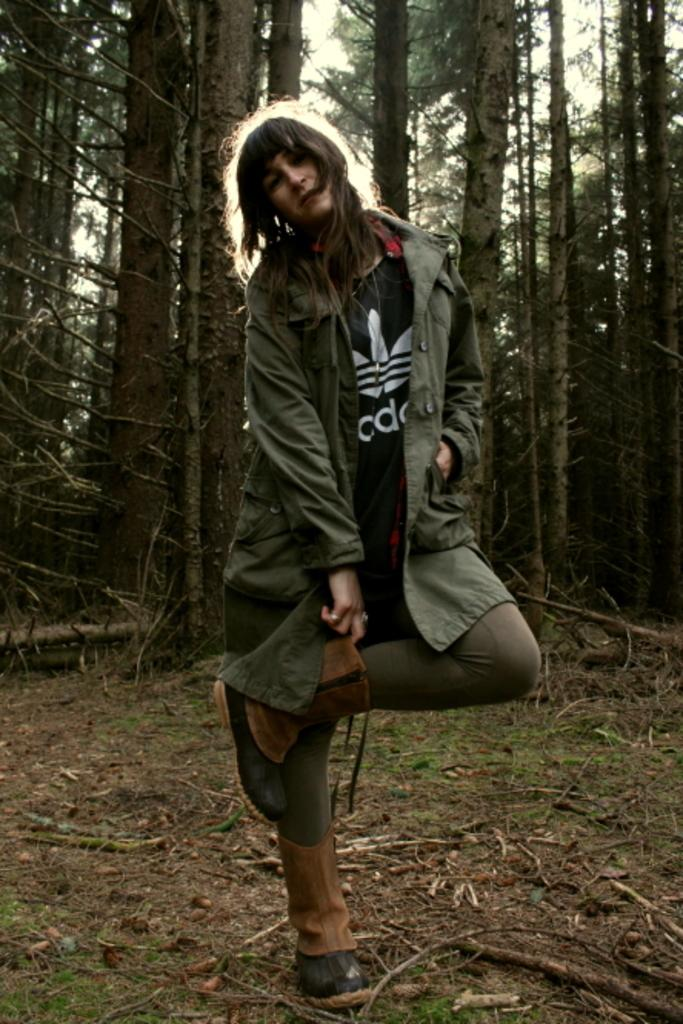Where was the picture taken? The picture was taken outside. What is the main subject in the center of the image? There is a person in the center of the image. What is the person wearing? The person is wearing a jacket. What surface is the person standing on? The person is standing on the ground. What type of vegetation can be seen in the background? There is green grass in the background. What else can be seen in the background? There are trees and the sky visible in the background. What type of knowledge is the person sharing on the tray in the image? There is no tray present in the image, and therefore no knowledge being shared on it. 